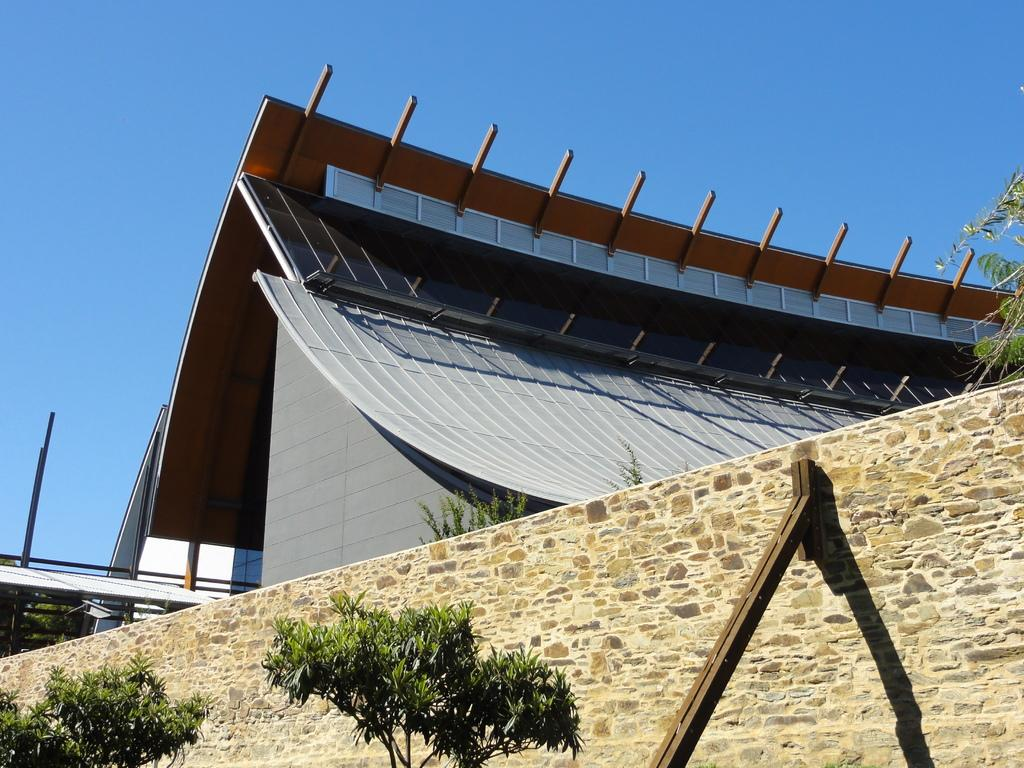What type of structure is visible in the image? There is a building in the image. What is located in front of the building? There is a wall in front of the building. What type of vegetation can be seen in the image? There are trees in the image. What is visible in the background of the image? The sky is visible in the background of the image. How many sheep are visible in the image? There are no sheep present in the image. What type of mist can be seen surrounding the building in the image? There is no mist visible in the image; it is a clear scene with the building, wall, trees, and sky. 